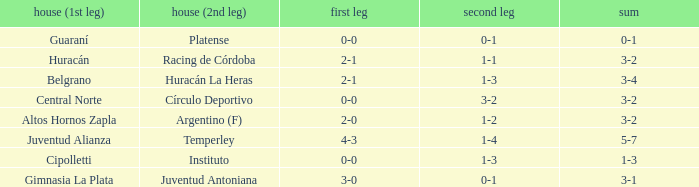What was the aggregate score that had a 1-2 second leg score? 3-2. 